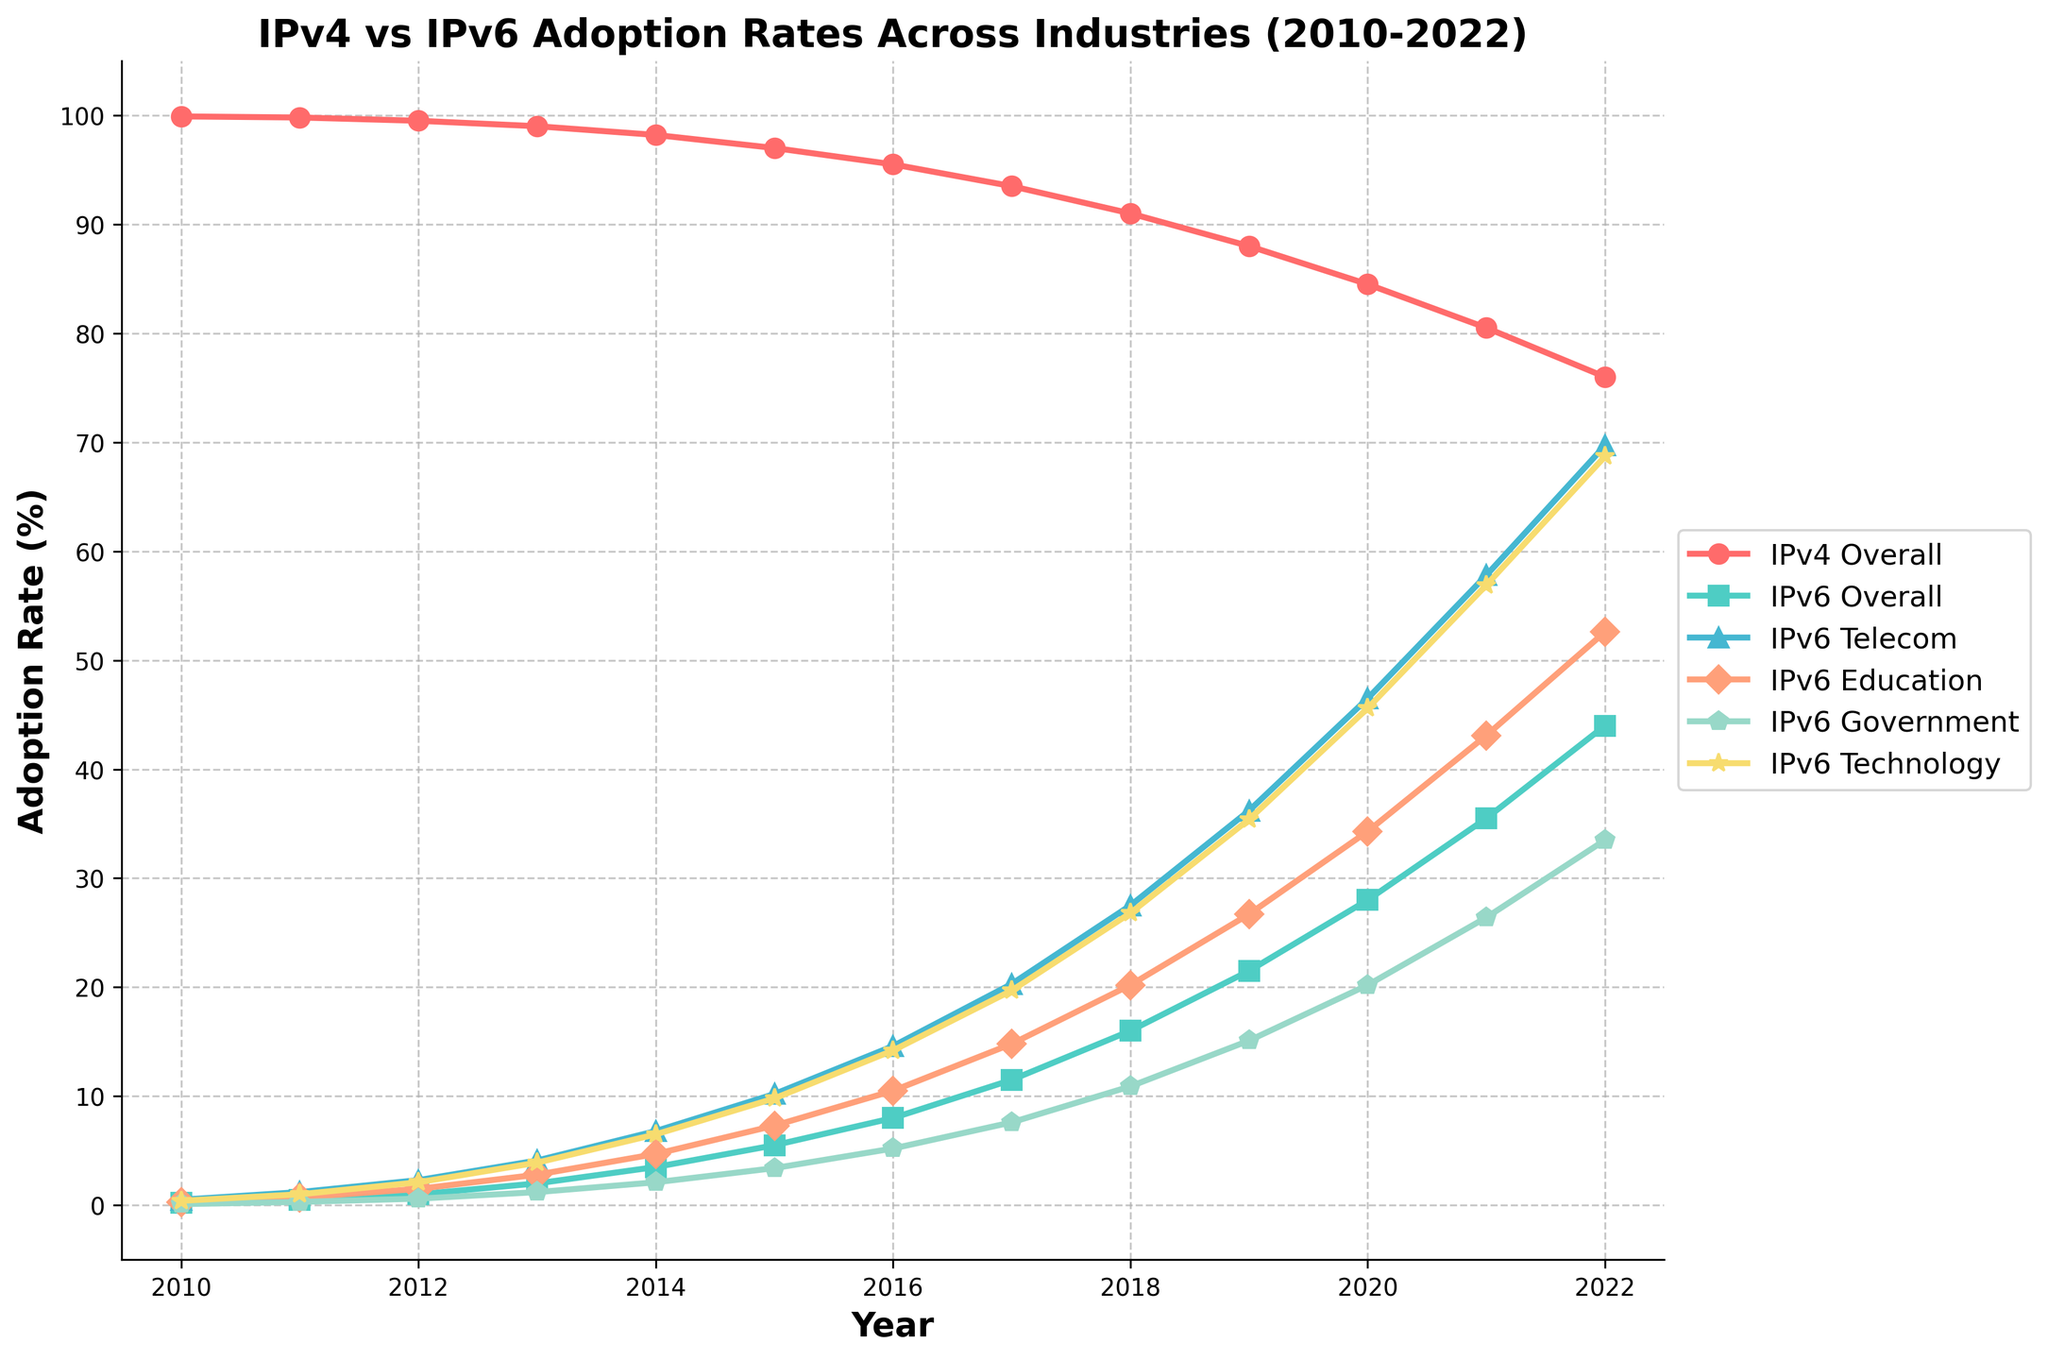Which industry had the highest IPv6 adoption rate in 2022? To find the industry with the highest IPv6 adoption rate in 2022, look for the highest point on the graph for the year 2022 among the industries listed. The highest point corresponds to the IPv6 Telecom industry.
Answer: IPv6 Telecom How much did the IPv6 adoption rate in the Government sector increase from 2010 to 2022? To calculate the increase, subtract the adoption rate in 2010 (0.1%) from the adoption rate in 2022 (33.5%) for the Government sector. The increase is 33.5 - 0.1 = 33.4%.
Answer: 33.4% What is the average IPv6 adoption rate in the Technology sector from 2010 to 2022? To find the average, sum the adoption rates for the Technology sector from 2010 to 2022 and divide by the number of years. (0.4 + 1.0 + 2.1 + 3.9 + 6.5 + 9.8 + 14.2 + 19.7 + 26.8 + 35.4 + 45.6 + 56.9 + 68.7) / 13 ≈ 22.6%
Answer: 22.6% In which year did overall IPv6 adoption reach 20% and how does it compare to the overall IPv4 rate in the same year? IPv6 adoption reached 20% in 2019. In the same year, the IPv4 overall adoption rate was 88%.
Answer: The two adoption rates in 2019 were 20% (IPv6) and 88% (IPv4) Which sector saw the largest increase in IPv6 adoption rate between 2015 and 2020? For each sector, subtract the 2015 rate from the 2020 rate: Telecom (46.5 - 10.2 = 36.3%), Education (34.3 - 7.3 = 27.0%), Government (20.2 - 3.4 = 16.8%), Technology (45.6 - 9.8 = 35.8%). The largest increase is in the Telecom sector with a 36.3% increase.
Answer: Telecom What was the adoption rate of IPv6 in Education in 2013 and how did it change by 2017? The adoption rate in Education in 2013 was 2.8%, and by 2017 it increased to 14.8%. The change is 14.8 - 2.8 = 12%.
Answer: Increased by 12% Which color represents the IPv6 Technology sector? To identify the color, look at the line representing the Technology sector. The Technology sector line is represented by a yellow color.
Answer: Yellow By how much did the overall IPv4 adoption rate decrease from 2010 to 2022? Subtract the 2022 overall IPv4 adoption rate (76.0%) from the 2010 rate (99.9%). The decrease is 99.9 - 76.0 = 23.9%.
Answer: 23.9% Which year saw the largest yearly increase in IPv6 adoption for the Telecom sector? Compare the yearly changes in IPv6 Telecom adoption: (2011-2010: 1.2 - 0.5 = 0.7), (2012-2011: 2.3 - 1.2 = 1.1), ..., (2021-2020: 57.8 - 46.5 = 11.3). The year with the largest increase is 2021 (11.3%).
Answer: 2021 